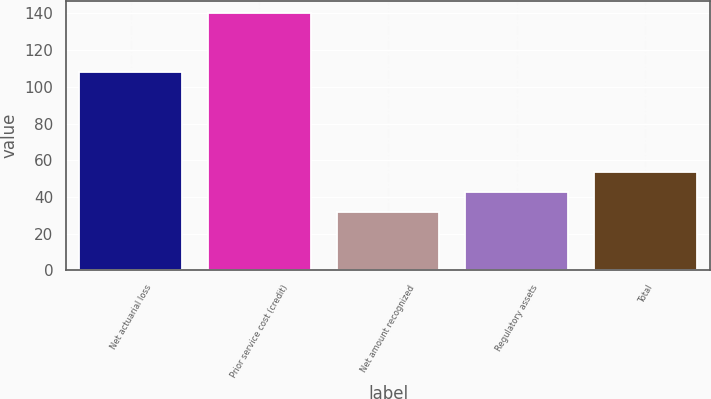Convert chart. <chart><loc_0><loc_0><loc_500><loc_500><bar_chart><fcel>Net actuarial loss<fcel>Prior service cost (credit)<fcel>Net amount recognized<fcel>Regulatory assets<fcel>Total<nl><fcel>108<fcel>140<fcel>32<fcel>42.8<fcel>53.6<nl></chart> 